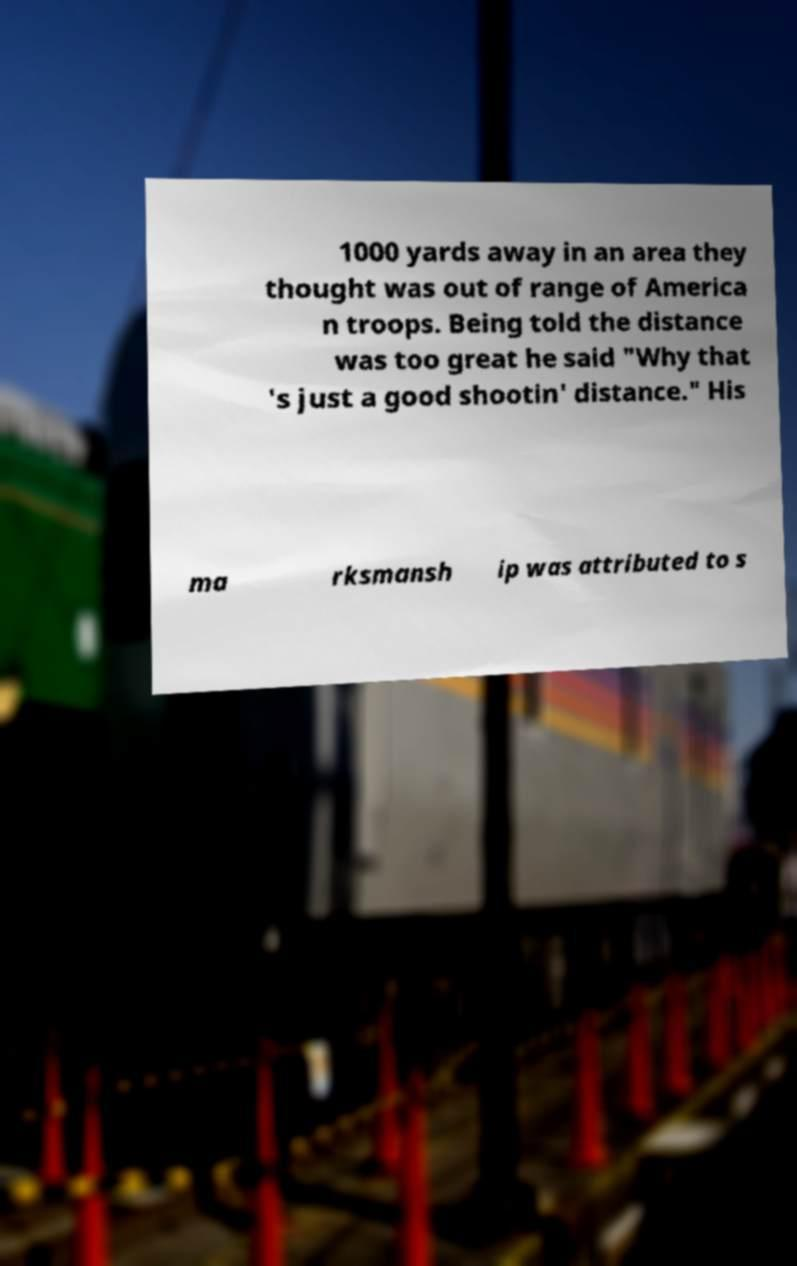Could you extract and type out the text from this image? 1000 yards away in an area they thought was out of range of America n troops. Being told the distance was too great he said "Why that 's just a good shootin' distance." His ma rksmansh ip was attributed to s 